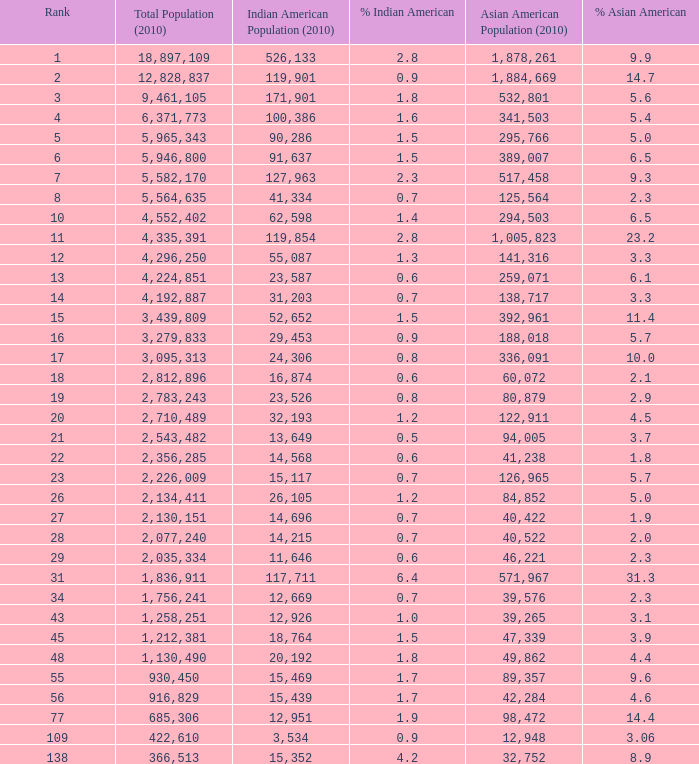When the asian american population is under 60,072, the indian american population exceeds 14,696, and indian americans constitute 4.2%, what is the total population? 366513.0. 